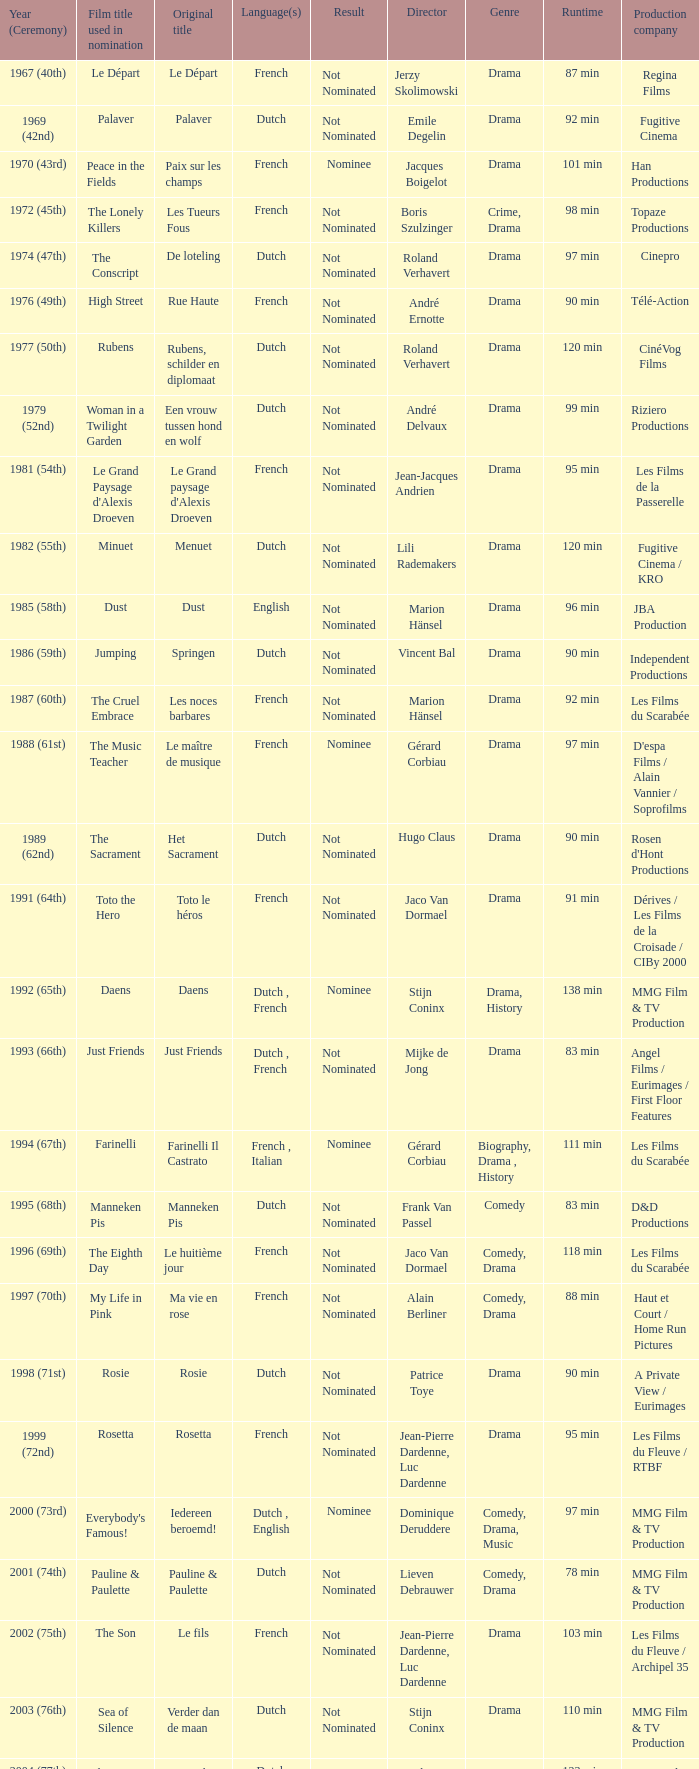What is the language of the film Rosie? Dutch. 